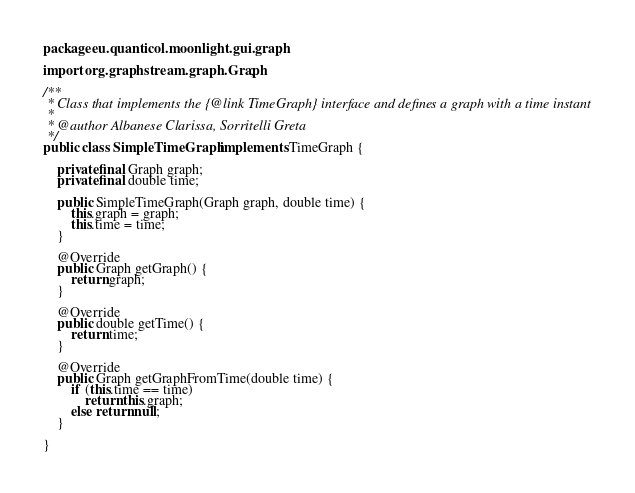Convert code to text. <code><loc_0><loc_0><loc_500><loc_500><_Java_>package eu.quanticol.moonlight.gui.graph;

import org.graphstream.graph.Graph;

/**
 * Class that implements the {@link TimeGraph} interface and defines a graph with a time instant
 *
 * @author Albanese Clarissa, Sorritelli Greta
 */
public class SimpleTimeGraph implements TimeGraph {

    private final Graph graph;
    private final double time;

    public SimpleTimeGraph(Graph graph, double time) {
        this.graph = graph;
        this.time = time;
    }

    @Override
    public Graph getGraph() {
        return graph;
    }

    @Override
    public double getTime() {
        return time;
    }

    @Override
    public Graph getGraphFromTime(double time) {
        if (this.time == time)
            return this.graph;
        else return null;
    }

}
</code> 